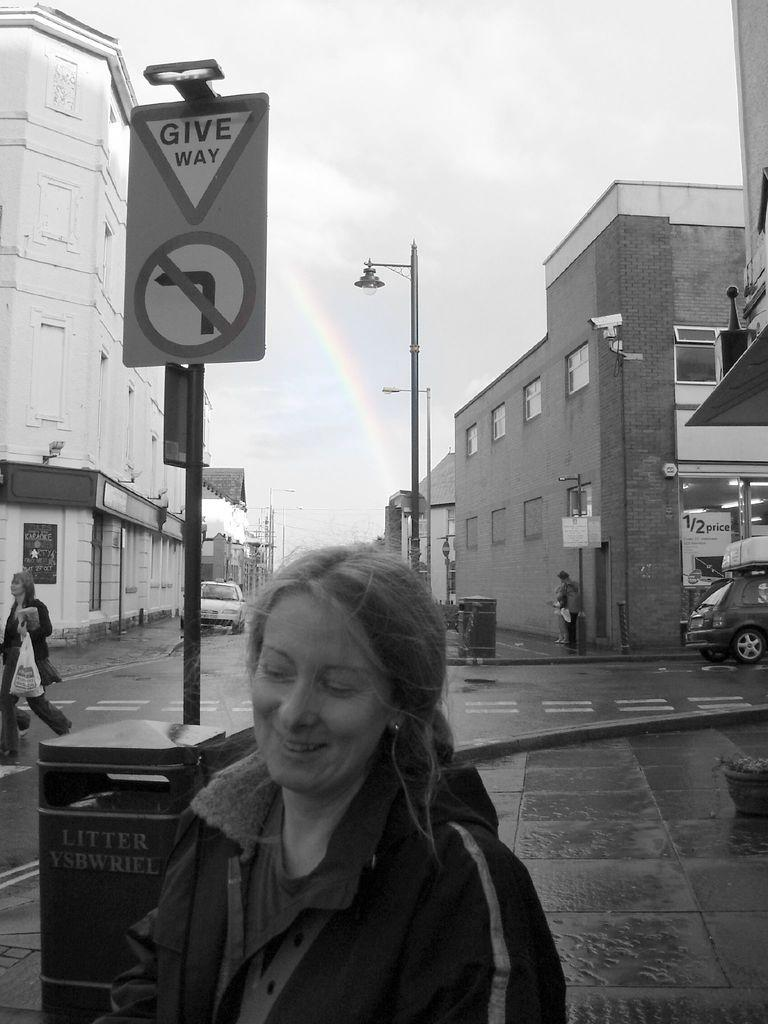Who or what can be seen in the image? There are people in the image. What else is visible on the road in the image? There are vehicles on the road in the image. Are there any informational or directional signs in the image? Yes, there are sign boards in the image. What structures are present to provide lighting in the image? There are lamp posts in the image. What type of structures can be seen on either side of the road in the image? There are buildings on either side of the road in the image. Can you tell me how many horses are present in the image? There are no horses present in the image. What type of oatmeal is being served at the restaurant in the image? There is no restaurant or oatmeal present in the image. 